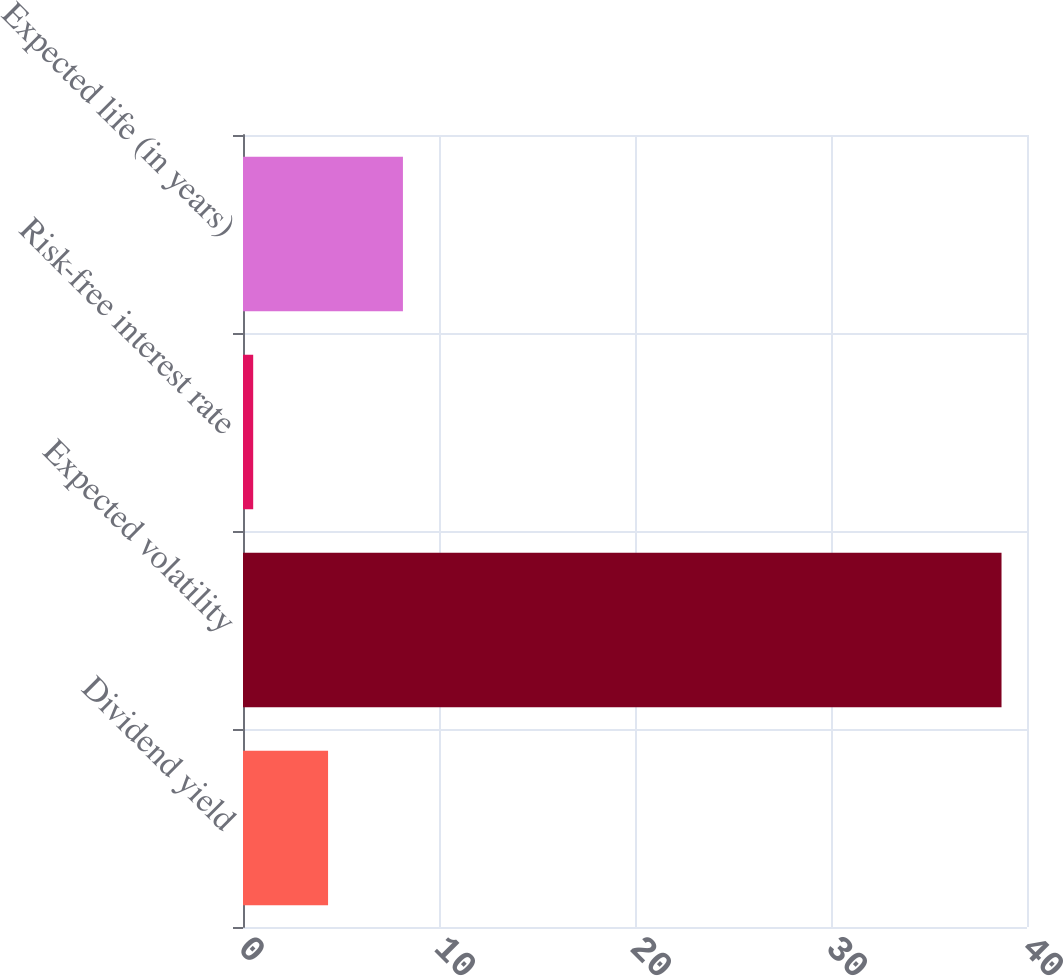<chart> <loc_0><loc_0><loc_500><loc_500><bar_chart><fcel>Dividend yield<fcel>Expected volatility<fcel>Risk-free interest rate<fcel>Expected life (in years)<nl><fcel>4.34<fcel>38.7<fcel>0.52<fcel>8.16<nl></chart> 